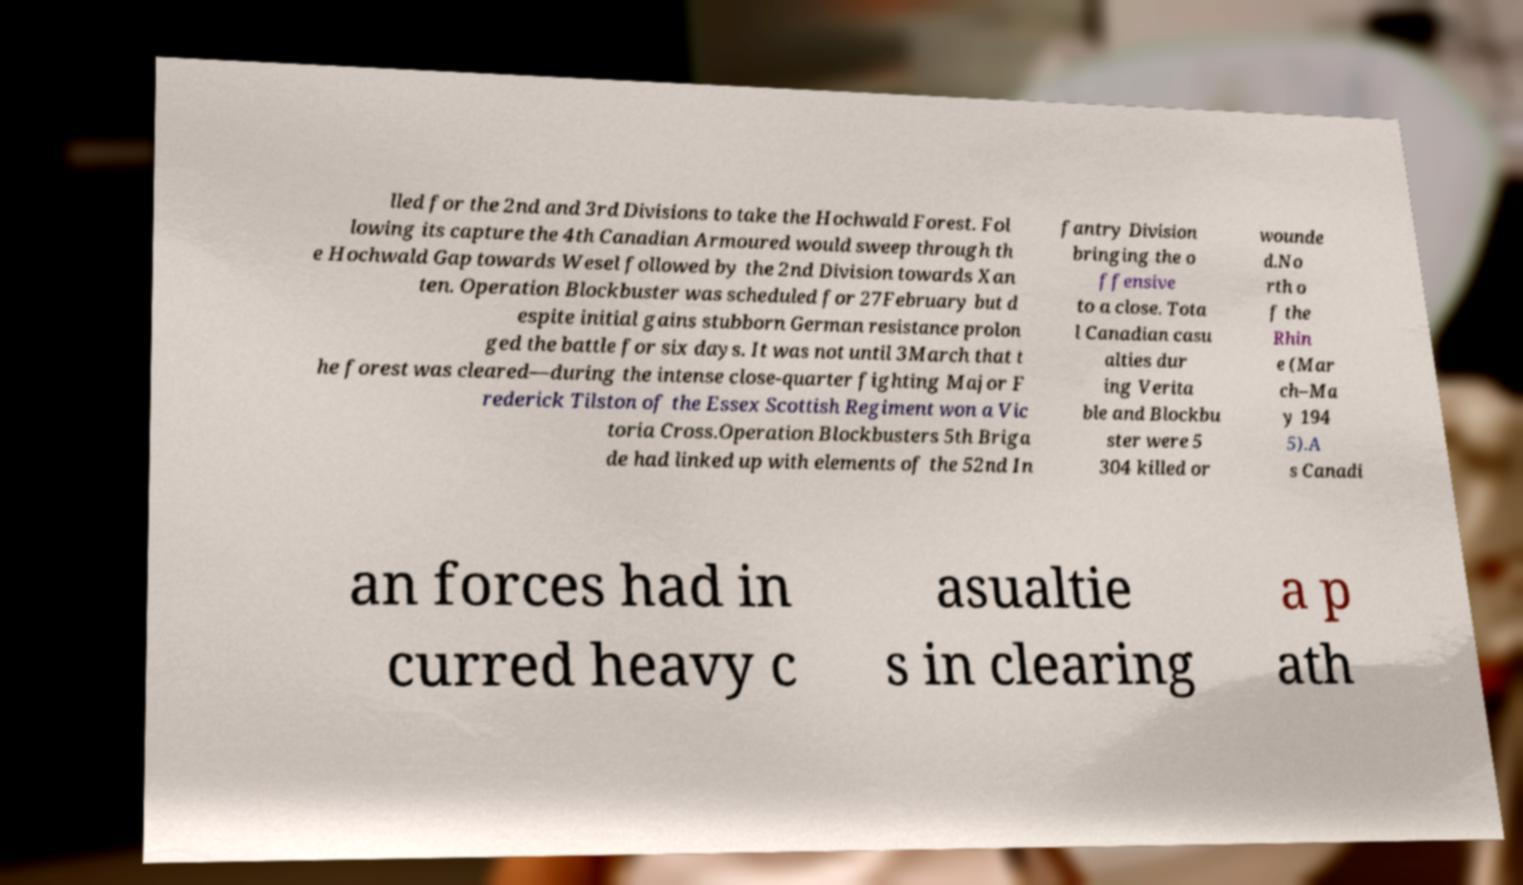Could you extract and type out the text from this image? lled for the 2nd and 3rd Divisions to take the Hochwald Forest. Fol lowing its capture the 4th Canadian Armoured would sweep through th e Hochwald Gap towards Wesel followed by the 2nd Division towards Xan ten. Operation Blockbuster was scheduled for 27February but d espite initial gains stubborn German resistance prolon ged the battle for six days. It was not until 3March that t he forest was cleared—during the intense close-quarter fighting Major F rederick Tilston of the Essex Scottish Regiment won a Vic toria Cross.Operation Blockbusters 5th Briga de had linked up with elements of the 52nd In fantry Division bringing the o ffensive to a close. Tota l Canadian casu alties dur ing Verita ble and Blockbu ster were 5 304 killed or wounde d.No rth o f the Rhin e (Mar ch–Ma y 194 5).A s Canadi an forces had in curred heavy c asualtie s in clearing a p ath 